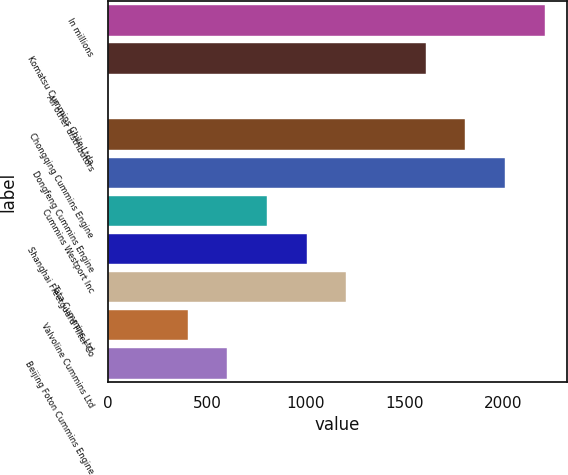Convert chart to OTSL. <chart><loc_0><loc_0><loc_500><loc_500><bar_chart><fcel>In millions<fcel>Komatsu Cummins Chile Ltda<fcel>All other distributors<fcel>Chongqing Cummins Engine<fcel>Dongfeng Cummins Engine<fcel>Cummins Westport Inc<fcel>Shanghai Fleetguard Filter Co<fcel>Tata Cummins Ltd<fcel>Valvoline Cummins Ltd<fcel>Beijing Foton Cummins Engine<nl><fcel>2212<fcel>1609<fcel>1<fcel>1810<fcel>2011<fcel>805<fcel>1006<fcel>1207<fcel>403<fcel>604<nl></chart> 